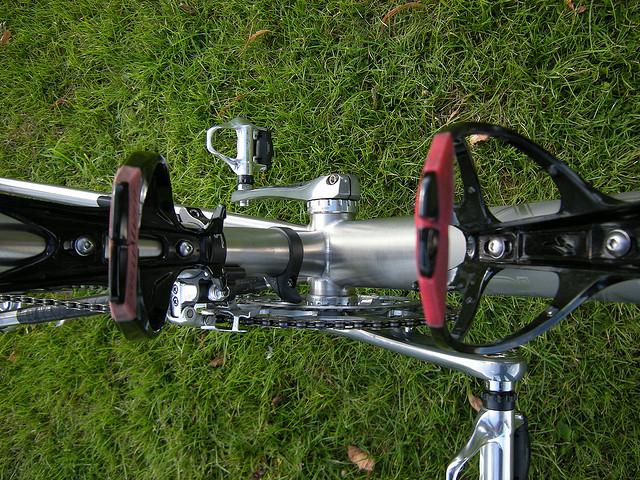What type of screwdriver would you need to remove parts?
Be succinct. Hex. What essential part of this bike is missing?
Keep it brief. Seat. What color is the grass on the picture?
Give a very brief answer. Green. 